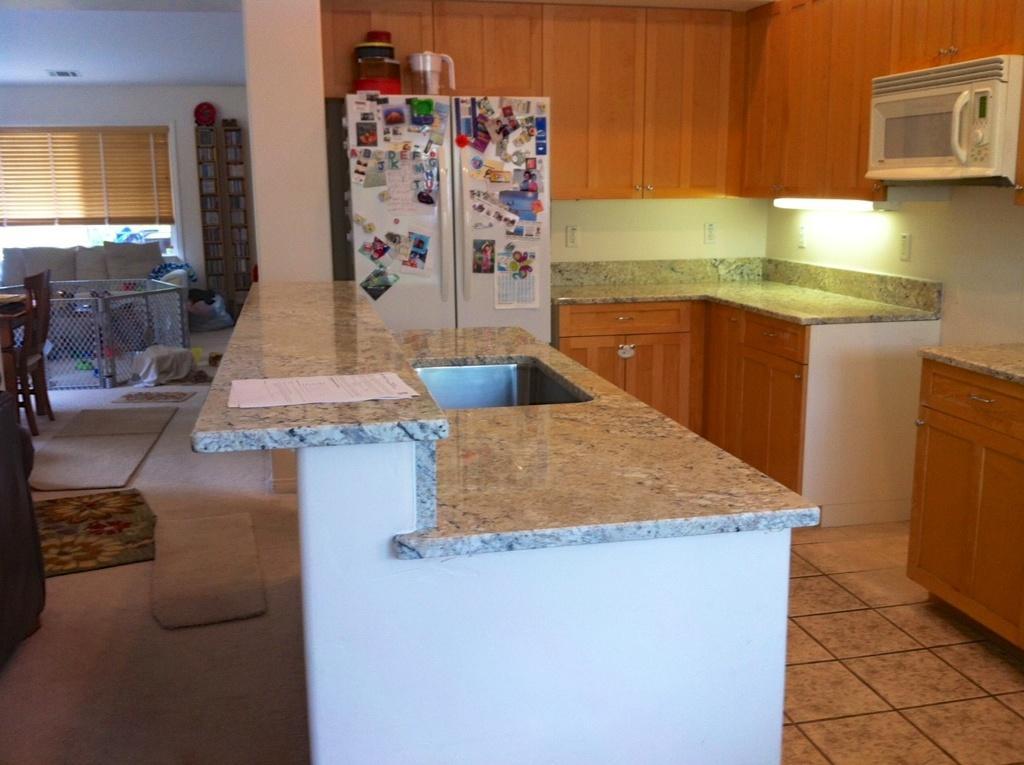Could you give a brief overview of what you see in this image? In this image we can see a fridge, there are some sticky notes on the fridge, there is a jar on the fridge, there are cupboards, kitchen slab, a sink, an oven, also we can see some papers on the slab, there are mats on the floor, there are some objects on the racks, there is a couch, chairs, a table, also we can see light, and the walls. 